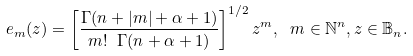<formula> <loc_0><loc_0><loc_500><loc_500>e _ { m } ( z ) = \left [ \frac { \Gamma ( n + | m | + \alpha + 1 ) } { m ! \ \Gamma ( n + \alpha + 1 ) } \right ] ^ { 1 / 2 } z ^ { m } , \ m \in \mathbb { N } ^ { n } , z \in \mathbb { B } _ { n } .</formula> 